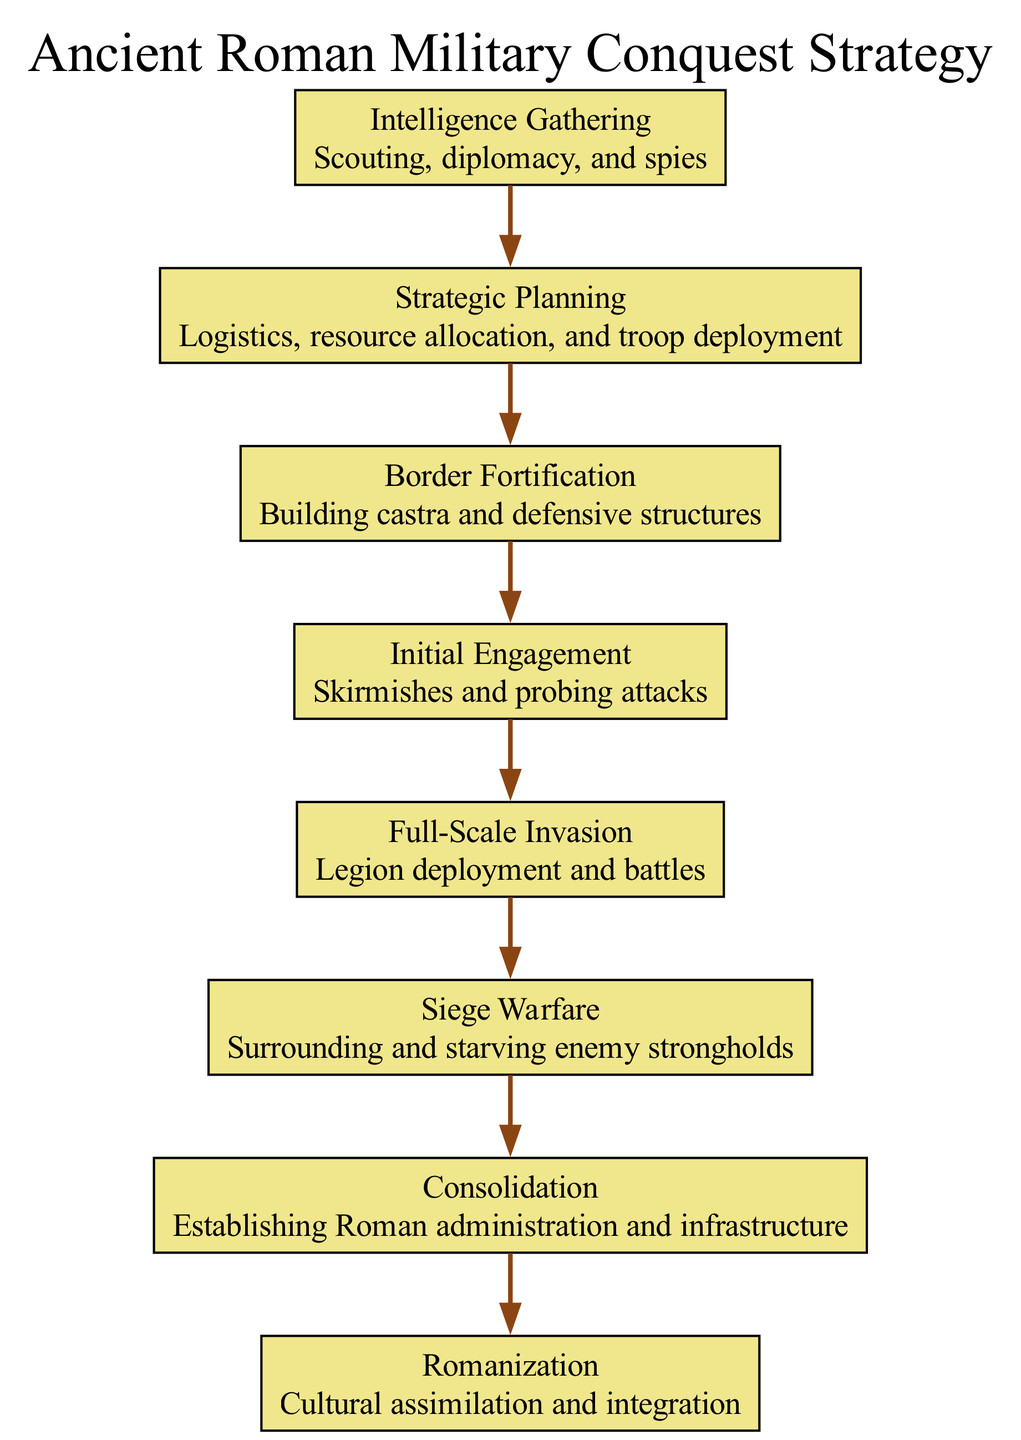What is the first phase in the diagram? The first phase is labeled in the diagram as "Intelligence Gathering." This can be directly seen from the position of the first node representing this phase.
Answer: Intelligence Gathering How many total phases are identified in the strategy? By counting the distinct phases listed in the diagram, it can be observed that there are eight phases represented by their respective nodes.
Answer: 8 What follows the phase of Initial Engagement? The diagram shows that the node following "Initial Engagement" is "Full-Scale Invasion." This is derived from the direct connection depicted in the edges linking the respective phases.
Answer: Full-Scale Invasion Which phase involves building castra and defensive structures? The specific details listed for the phase "Border Fortification" include building castra and defensive structures, as explicitly stated in the details section of that node.
Answer: Border Fortification What is the last phase depicted in the diagram? The last node in the sequence of phases indicates "Romanization," making it the final phase according to the arrangement in the diagram.
Answer: Romanization Which phases focus on engagement in battle? The phases involving engagement in battle are "Initial Engagement" and "Full-Scale Invasion." Both are explicitly linked to combat actions, which can be identified by looking through the descriptive details provided.
Answer: Initial Engagement, Full-Scale Invasion How does the phase of Siege Warfare relate to the earlier phases? "Siege Warfare" follows "Full-Scale Invasion" and can be understood as a continuation of the military strategy, indicating that after engaging in full-scale battles, Roman forces would proceed to besiege enemy strongholds, as sequentially shown in the diagram flow.
Answer: It follows Full-Scale Invasion Which two phases are focused on post-conquest strategy? The phases that relate to post-conquest strategies are "Consolidation" and "Romanization," as they are concerned with establishing administration and cultural integration after military conquests. They can be located towards the end of the diagram, highlighting their role in the latter part of the military strategy.
Answer: Consolidation, Romanization What type of diagram is this, and what is its purpose? This block diagram visually represents the sequential phases of a military strategy, effectively summarizing the steps and elements involved in the ancient Roman military conquest strategy. It helps in understanding the flow and organization of military actions and strategies.
Answer: Block Diagram, military strategy 